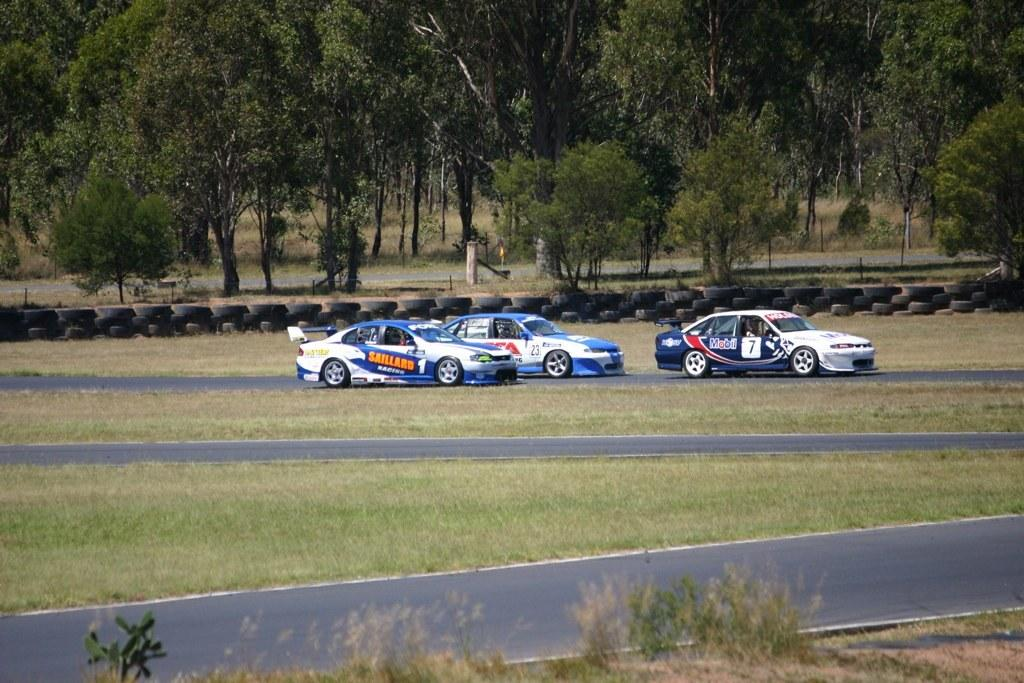How many cars can be seen on the road in the image? There are three cars on the road in the image. What type of landscape is visible at the bottom of the image? Grassy lands are visible at the bottom of the image. What is present at the bottom of the image besides grassy lands? Roads are present at the bottom of the image. What can be seen in the background of the image? In the background of the image, there are arranged tyres and trees. What type of soup is being served in the image? There is no soup present in the image. What type of apparel is being worn by the trees in the image? Trees do not wear apparel; they are natural vegetation. 